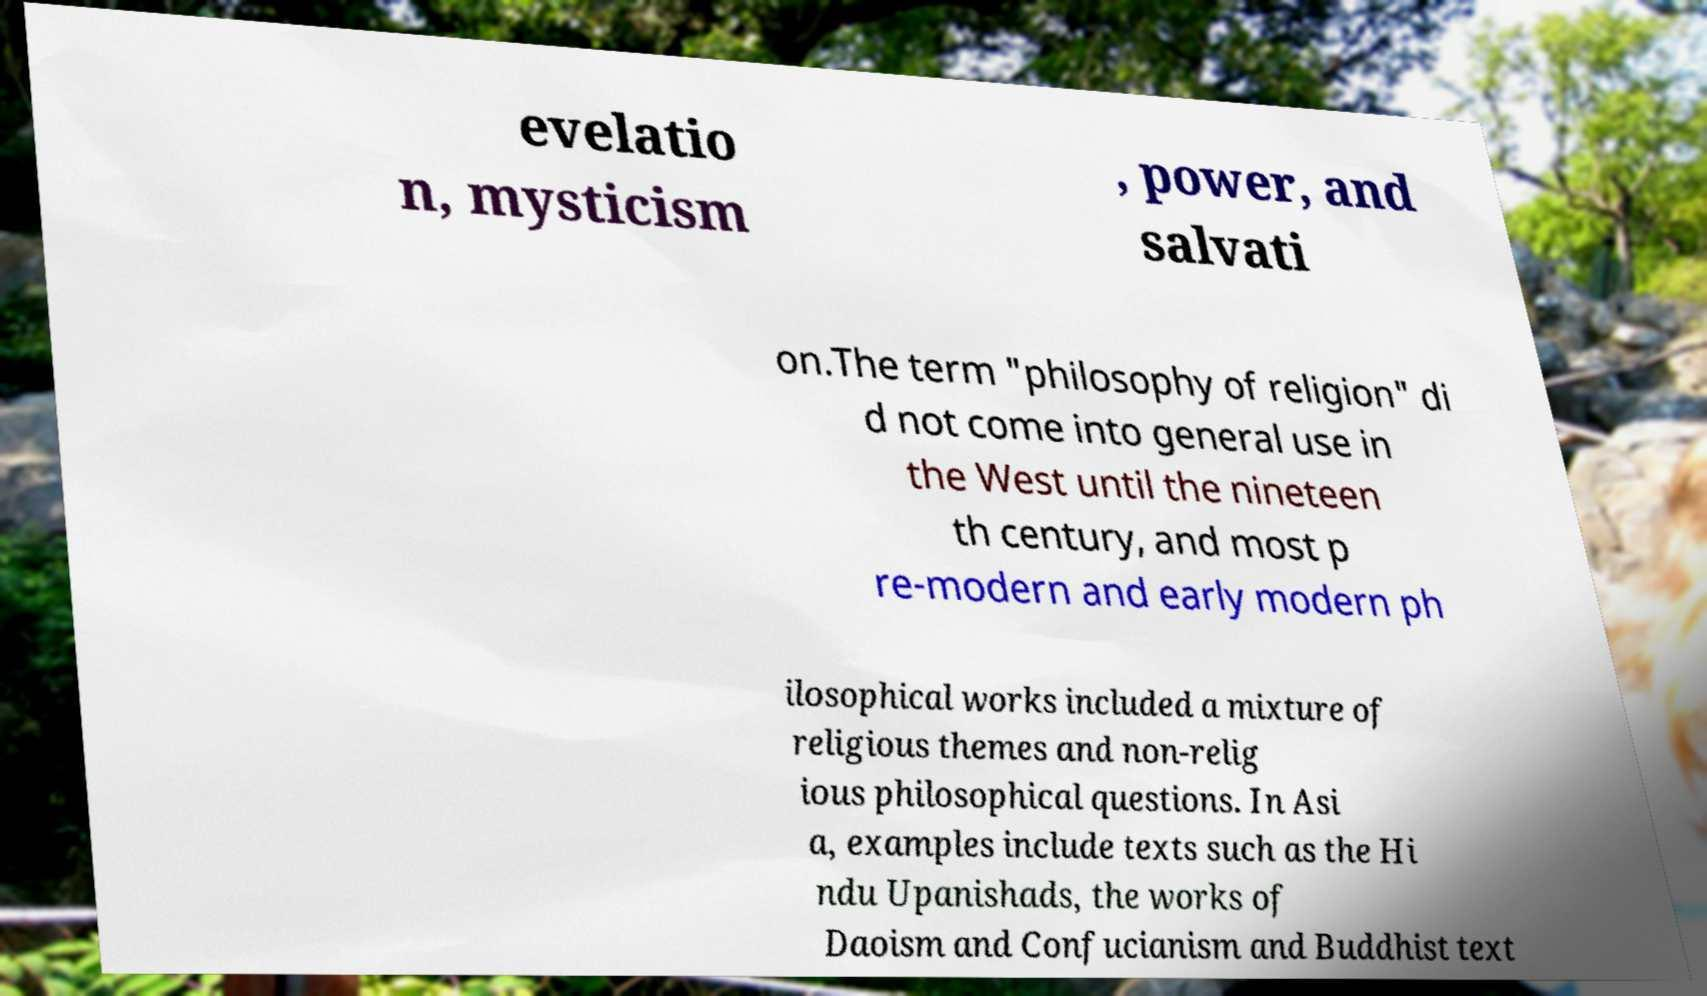Please identify and transcribe the text found in this image. evelatio n, mysticism , power, and salvati on.The term "philosophy of religion" di d not come into general use in the West until the nineteen th century, and most p re-modern and early modern ph ilosophical works included a mixture of religious themes and non-relig ious philosophical questions. In Asi a, examples include texts such as the Hi ndu Upanishads, the works of Daoism and Confucianism and Buddhist text 